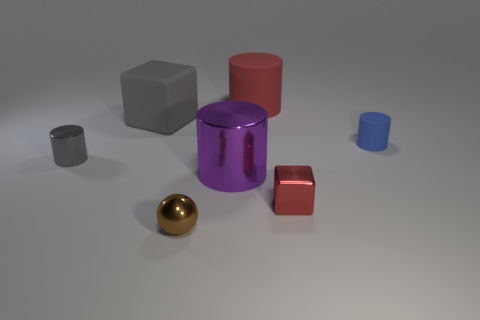Subtract all small gray cylinders. How many cylinders are left? 3 Subtract all purple cylinders. How many cylinders are left? 3 Subtract 1 cylinders. How many cylinders are left? 3 Add 3 balls. How many objects exist? 10 Subtract all cylinders. How many objects are left? 3 Subtract all brown cylinders. Subtract all cyan balls. How many cylinders are left? 4 Add 7 tiny blocks. How many tiny blocks are left? 8 Add 6 small red shiny things. How many small red shiny things exist? 7 Subtract 1 gray blocks. How many objects are left? 6 Subtract all small purple shiny cylinders. Subtract all big cylinders. How many objects are left? 5 